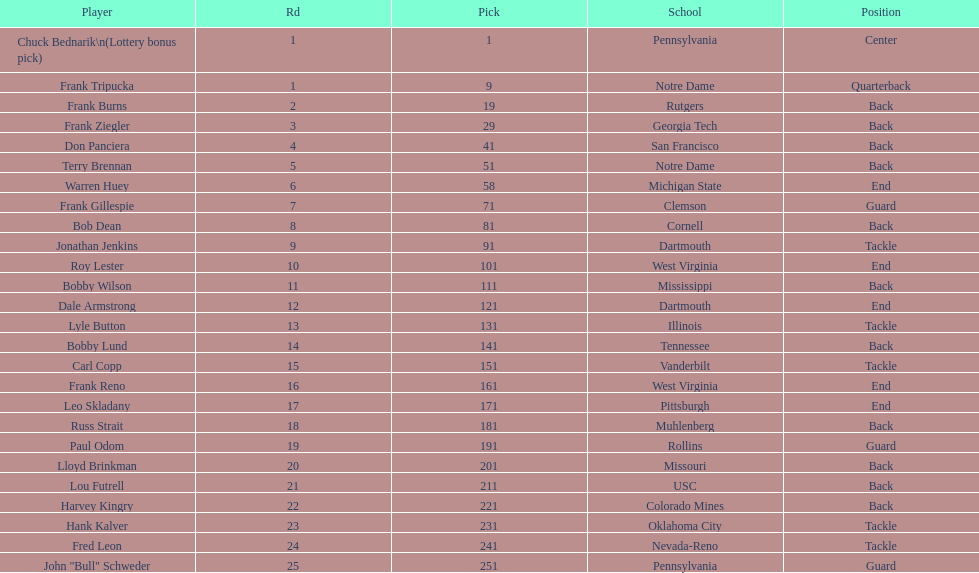Was chuck bednarik or frank tripucka the first draft pick? Chuck Bednarik. 